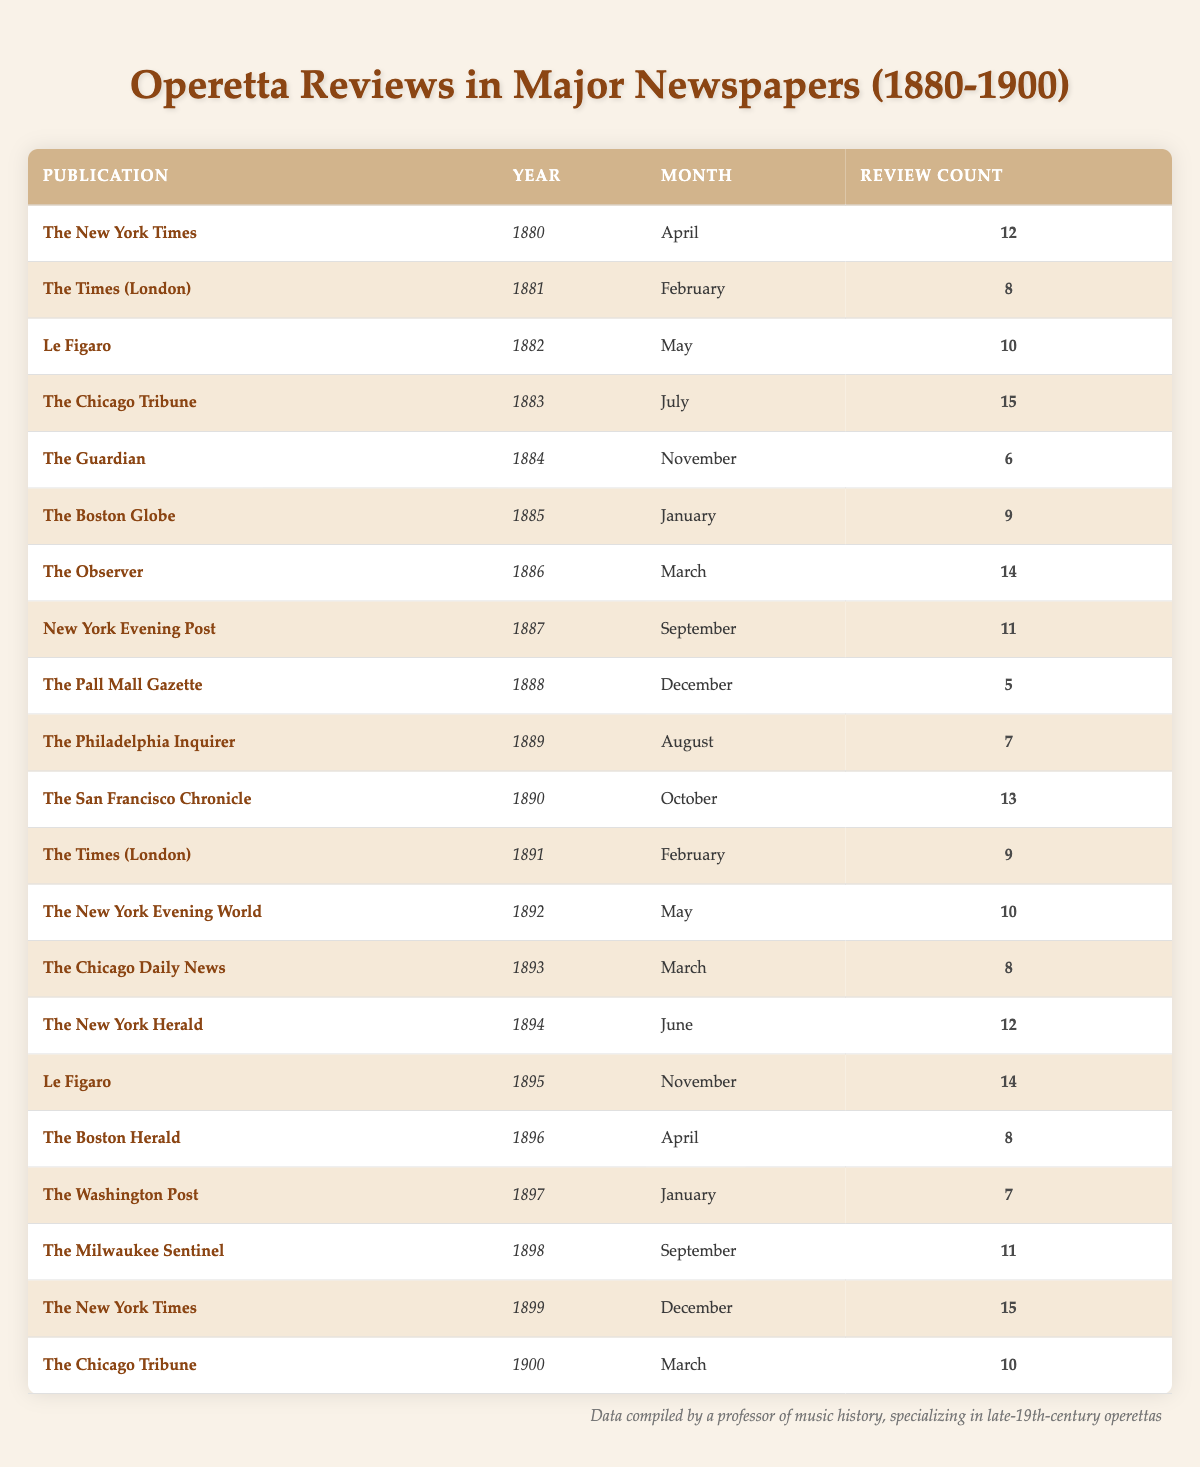What is the total number of operetta reviews published in the year 1880? In 1880, there is only one entry in the table for "The New York Times," which indicates that there were 12 operetta reviews published that year.
Answer: 12 Which publication had the highest review count in 1883? The table shows that "The Chicago Tribune" published 15 reviews in July 1883, which is the highest count listed for that year.
Answer: The Chicago Tribune Is it true that "Le Figaro" had more reviews in 1895 than in 1882? In 1895, "Le Figaro" had 14 reviews while in 1882, it had 10 reviews. Since 14 is greater than 10, the statement is true.
Answer: Yes How many total reviews were published in the years 1896 and 1898 combined? From the table, "The Boston Herald" had 8 reviews in 1896 and "The Milwaukee Sentinel" had 11 reviews in 1898. Adding these gives 8 + 11 = 19 total reviews for both years.
Answer: 19 What is the average number of reviews per year from 1880 to 1900? To find the average, count the total reviews: 12 + 8 + 10 + 15 + 6 + 9 + 14 + 11 + 5 + 7 + 13 + 9 + 10 + 8 + 12 + 14 + 8 + 7 + 11 + 15 + 10 =  248. There are 21 entries (one for each review), so the average is 248/21 ≈ 11.76.
Answer: Approximately 11.76 Which year had the least number of reviews published overall? By examining the review counts across all years, the lowest count is 5 reviews from "The Pall Mall Gazette" in 1888. Consequently, 1888 is the year with the least reviews overall.
Answer: 1888 Was "The Guardian" the only publication to review operettas in November? The table shows that "The Guardian" had 6 reviews in November 1884, and there are no other entries for November in any other year. Hence, it is true that it was the only publication to do so in that month.
Answer: Yes Which publication had reviews in both 1886 and 1892? The "New York Evening Post" is the publication that appears in 1887 (not 1886) and again in 1892, so it does not meet the criteria. However, there are no entries that denote the same publication appearing in both years within the provided data.
Answer: No What was the difference in the number of reviews between the years with the highest and lowest counts? The highest count in the table is 15 reviews from both "The Chicago Tribune" in 1883 and "The New York Times" in 1899, while the lowest count is 5 reviews from "The Pall Mall Gazette" in 1888. Thus, the difference is 15 - 5 = 10.
Answer: 10 